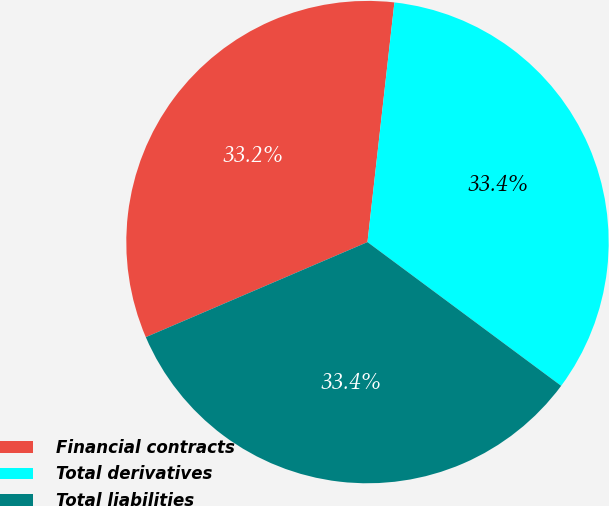<chart> <loc_0><loc_0><loc_500><loc_500><pie_chart><fcel>Financial contracts<fcel>Total derivatives<fcel>Total liabilities<nl><fcel>33.23%<fcel>33.38%<fcel>33.39%<nl></chart> 